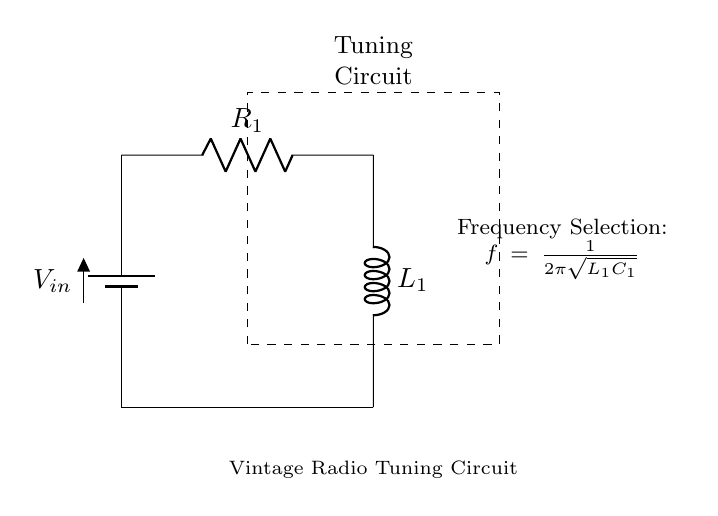What is the input voltage of the circuit? The input voltage is represented by the battery symbol labeled V_in at the top of the circuit diagram.
Answer: V_in What type of component is R_1? R_1 is marked with an "R" indicating it is a resistor, which is used to limit the current in the circuit.
Answer: Resistor What is L_1 in this circuit? L_1 is marked with an "L," indicating it is an inductor, which is used to store energy in the form of a magnetic field.
Answer: Inductor What function does the tuning circuit serve? The tuning circuit is designed for frequency selection, allowing the user to select a specific frequency for tuning the vintage radio.
Answer: Frequency selection How is the frequency calculated in this circuit? The frequency is calculated using the formula f = 1/(2π√(L_1C_1)), which shows the relationship between frequency, inductance, and capacitance in the circuit.
Answer: f = 1/(2π√(L_1C_1)) What happens if R_1 is increased? Increasing R_1 would generally decrease the current flowing through the circuit, as resistors limit the flow of electricity according to Ohm's Law.
Answer: Decrease current What effect does L_1 have on the overall frequency response? L_1 provides inductance that affects the circuit's ability to resonate at specific frequencies, thus influencing the tuning performance of the radio.
Answer: Affects resonance 